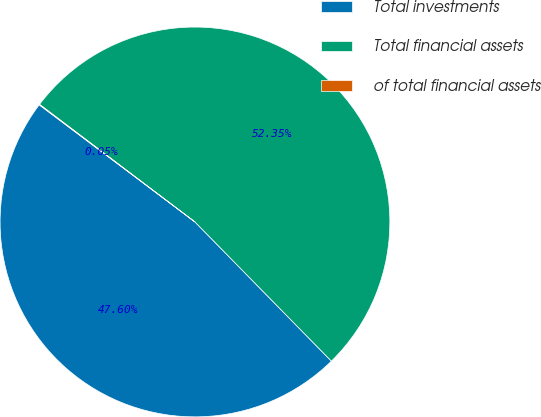Convert chart to OTSL. <chart><loc_0><loc_0><loc_500><loc_500><pie_chart><fcel>Total investments<fcel>Total financial assets<fcel>of total financial assets<nl><fcel>47.6%<fcel>52.35%<fcel>0.05%<nl></chart> 